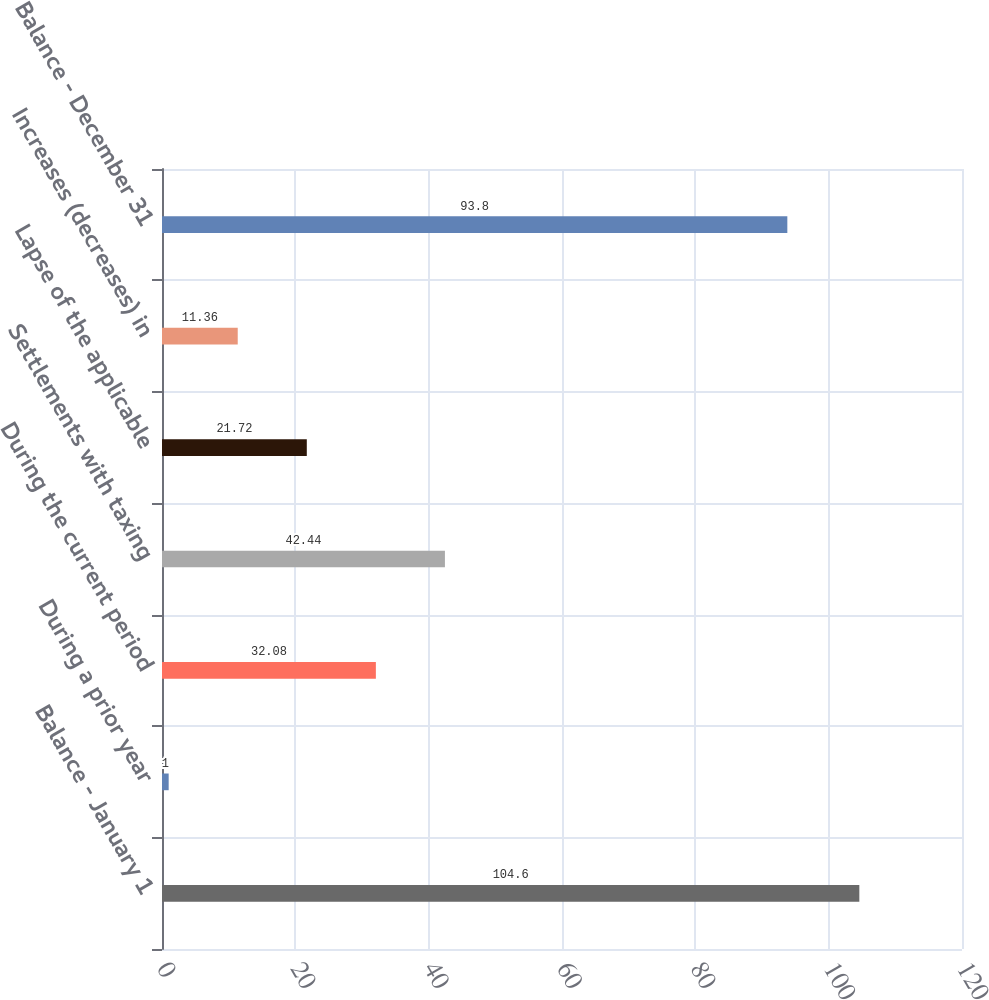Convert chart to OTSL. <chart><loc_0><loc_0><loc_500><loc_500><bar_chart><fcel>Balance - January 1<fcel>During a prior year<fcel>During the current period<fcel>Settlements with taxing<fcel>Lapse of the applicable<fcel>Increases (decreases) in<fcel>Balance - December 31<nl><fcel>104.6<fcel>1<fcel>32.08<fcel>42.44<fcel>21.72<fcel>11.36<fcel>93.8<nl></chart> 